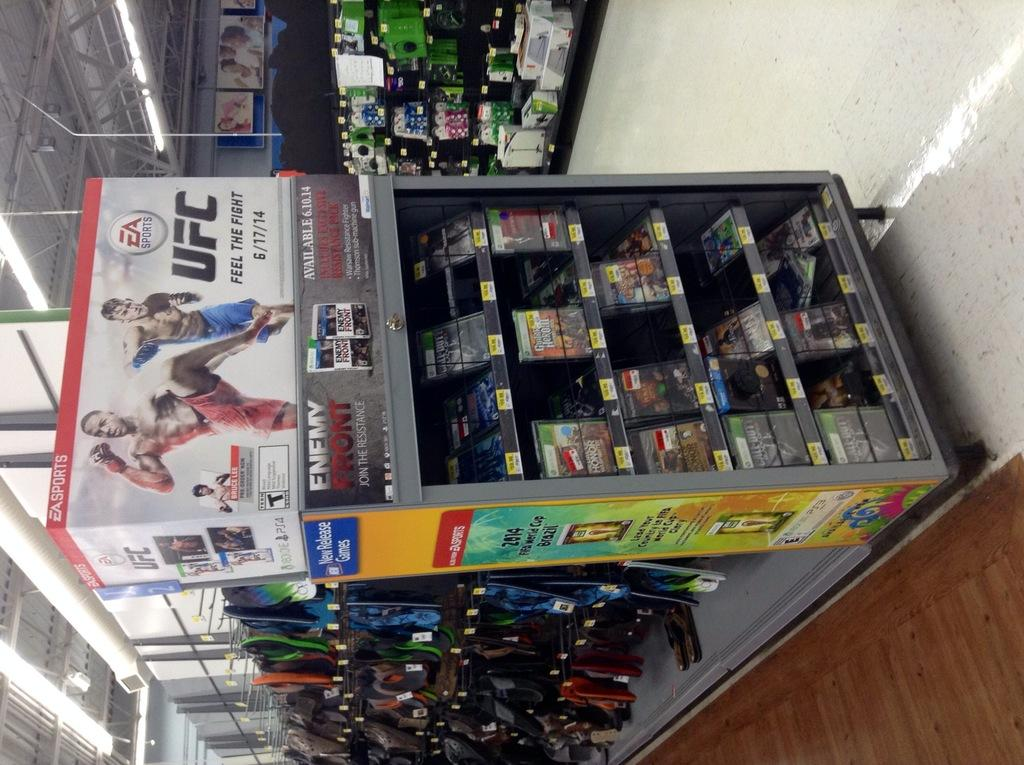<image>
Describe the image concisely. An advertisement for a video game that comes out on June 17. 